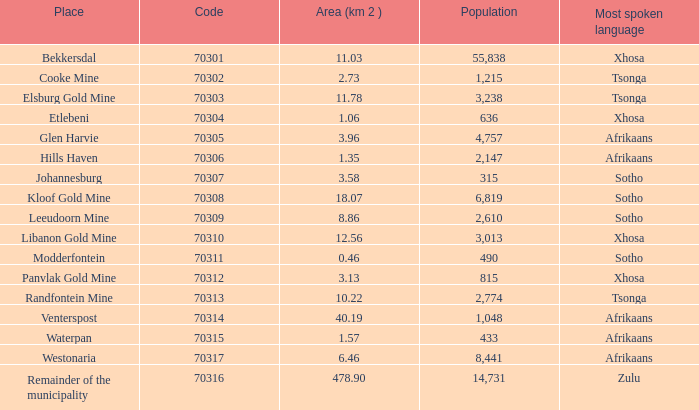What is the low code for glen harvie with a population greater than 2,774? 70305.0. 